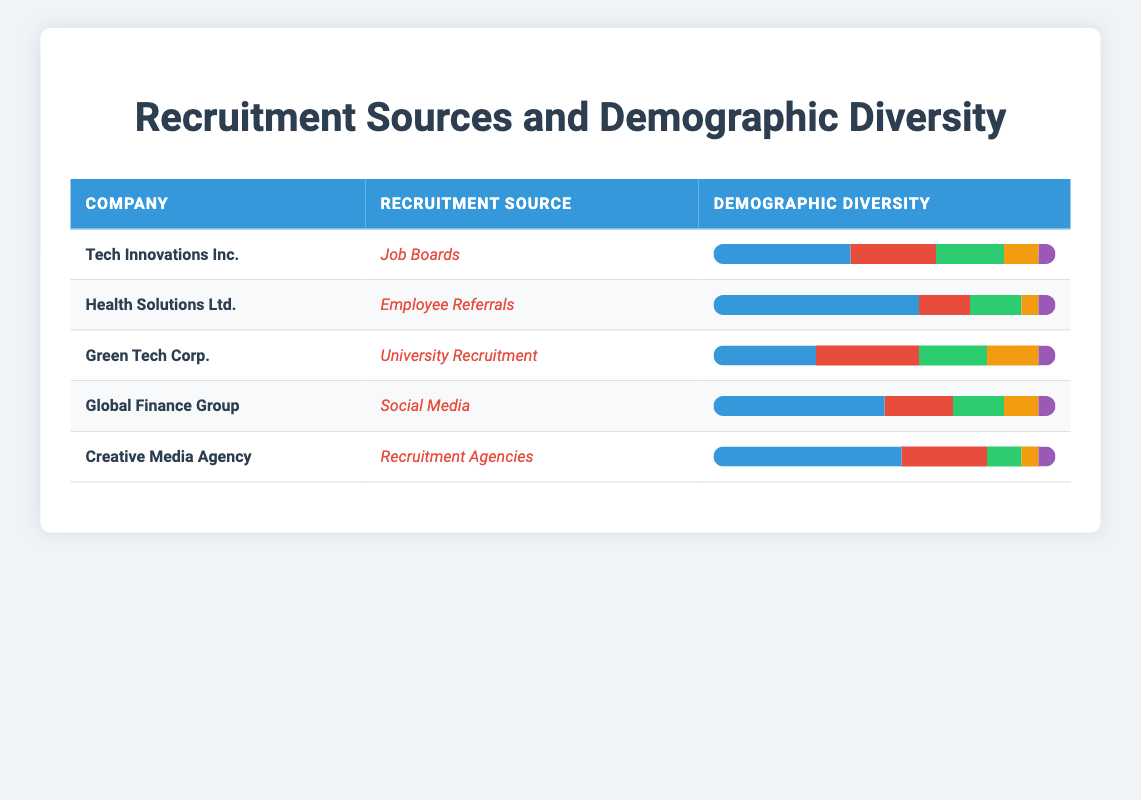What is the recruitment source for Tech Innovations Inc.? Tech Innovations Inc. is associated with the recruitment source "Job Boards" as indicated in the table.
Answer: Job Boards Which company has the highest percentage of hired White candidates? By examining the demographic breakdown, Health Solutions Ltd. has the highest percentage of White candidates at 60%.
Answer: Health Solutions Ltd What is the total percentage of Black candidates hired across all companies listed? To find the total percentage of Black candidates, we add the percentages: 25 (Tech Innovations Inc.) + 15 (Health Solutions Ltd.) + 30 (Green Tech Corp.) + 20 (Global Finance Group) + 25 (Creative Media Agency) = 115%. This is consistent with the total number of companies (5). Therefore, the average percentage is 115/5 = 23%.
Answer: 23% Does University Recruitment have more Asian candidates compared to Social Media recruitment? Green Tech Corp. under University Recruitment has 15% Asian candidates, while Global Finance Group under Social Media has 10% Asian candidates. Since 15% is greater than 10%, the statement is true.
Answer: Yes What is the diversity of hired candidates in terms of percentages for Creative Media Agency? Creative Media Agency's demographic diversity is broken down as follows: White 55%, Black 25%, Hispanic 10%, Asian 5%, and Other 5%. These equal total contributions from diverse backgrounds.
Answer: White 55%, Black 25%, Hispanic 10%, Asian 5%, Other 5% Which recruitment source yields the lowest percentage of Hispanic candidates among the companies? By examining the reported percentages, Creative Media Agency has the lowest percentage of Hispanic candidates at 10%. All others have higher percentages: Job Boards 20%, Employee Referrals 15%, University Recruitment 20%, and Social Media 15%.
Answer: Creative Media Agency What is the average percentage of diversity among hired candidates for companies that used Employee Referrals? Employee Referrals is used by Health Solutions Ltd. only, reporting 60% White, 15% Black, 15% Hispanic, 5% Asian, and 5% Other. The average percentage across these is simple as there's only one company to analyze.
Answer: 100% How does the demographic diversity of Green Tech Corp. compare to Tech Innovations Inc. in terms of overall diversity? Green Tech Corp. has an equal representation with 30% White, 30% Black, 20% Hispanic, 15% Asian, and 5% Other, while Tech Innovations Inc. represents 40% White, 25% Black, 20% Hispanic, 10% Asian, and 5% Other. Therefore, they are less diverse than Tech Innovations in terms of White representation, being more balanced otherwise.
Answer: More balanced What percentage of hired candidates are classified as 'Other' across all companies? By adding the 'Other' percentages: 5 (Tech Innovations Inc.) + 5 (Health Solutions Ltd.) + 5 (Green Tech Corp.) + 5 (Global Finance Group) + 5 (Creative Media Agency) = 25%. Then dividing across the 5 companies gives us an average of 25/5 = 5%.
Answer: 5% 